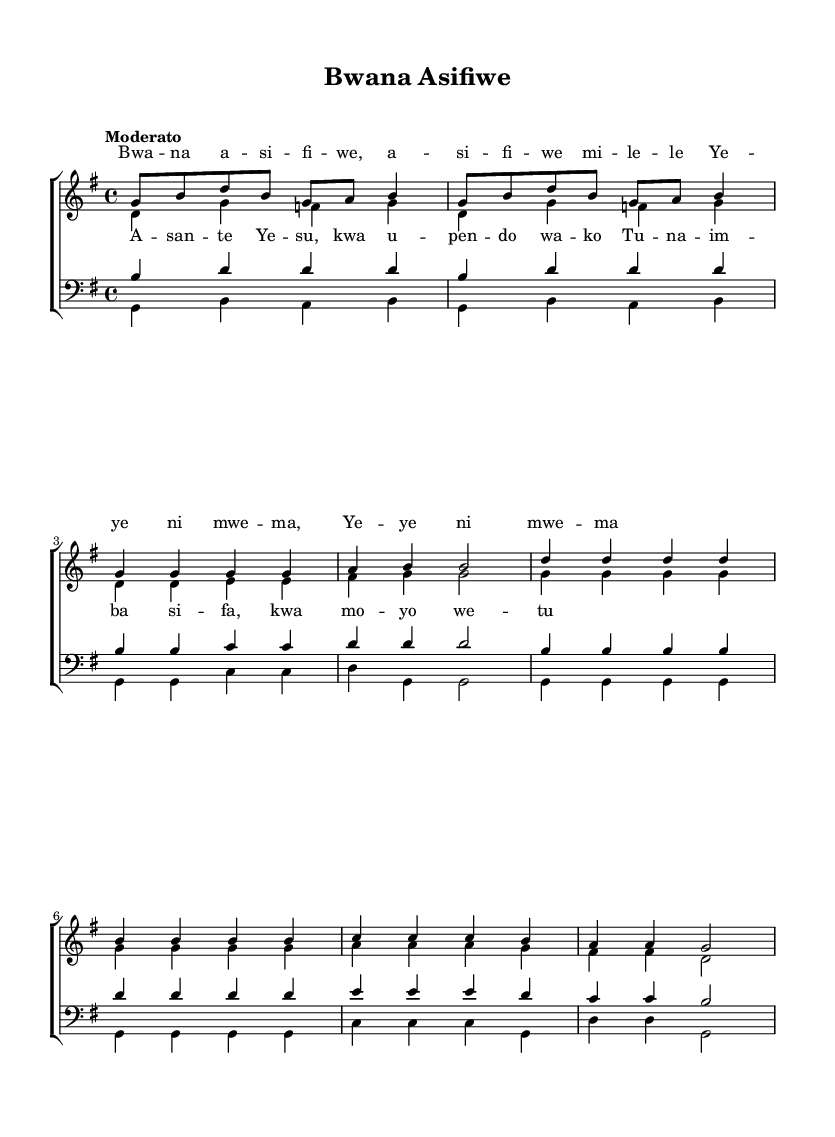What is the key signature of this music? The key signature is G major, which has one sharp (F#). You can identify this by looking for the sharp symbol on the staff, and confirming that the piece is written in the G major scale pattern.
Answer: G major What is the time signature of this music? The time signature is 4/4, often referred to as "common time." This can be identified by the two numbers at the beginning of the piece, where the top number indicates 4 beats per measure and the bottom number indicates that the quarter note gets one beat.
Answer: 4/4 What is the tempo marking for the piece? The tempo marking is "Moderato." This is typically indicated above the staff at the beginning of the piece and describes a moderate speed for the music performance.
Answer: Moderato How many measures are in the chorus section? The chorus section has 8 measures. You can count the number of vertical lines dividing the music into sections, specifically the part where the lyrics indicate the chorus starts and where it ends.
Answer: 8 measures What is the highest note in the soprano part? The highest note in the soprano part is B. You can determine this by analyzing the notes written in the soprano staff, particularly during the chorus and the verse, and identifying the highest pitch reached.
Answer: B What language are the lyrics sung in? The lyrics are sung in Swahili. This can be inferred from the specific words and phrases used in the lyrics, which are characteristic of the Swahili language commonly found in African gospel music.
Answer: Swahili What form does this hymn follow based on the structure? The hymn follows a verse-chorus form. This is evident by the distinct separation of the verse and chorus sections in the music, where the verse introduces thematic material that is followed by the repeated chorus.
Answer: Verse-chorus form 